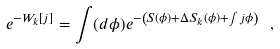Convert formula to latex. <formula><loc_0><loc_0><loc_500><loc_500>e ^ { - W _ { k } [ j ] } = \int ( d \phi ) e ^ { - \left ( S ( \phi ) + \Delta S _ { k } ( \phi ) + \int j \phi \right ) } \, \ ,</formula> 